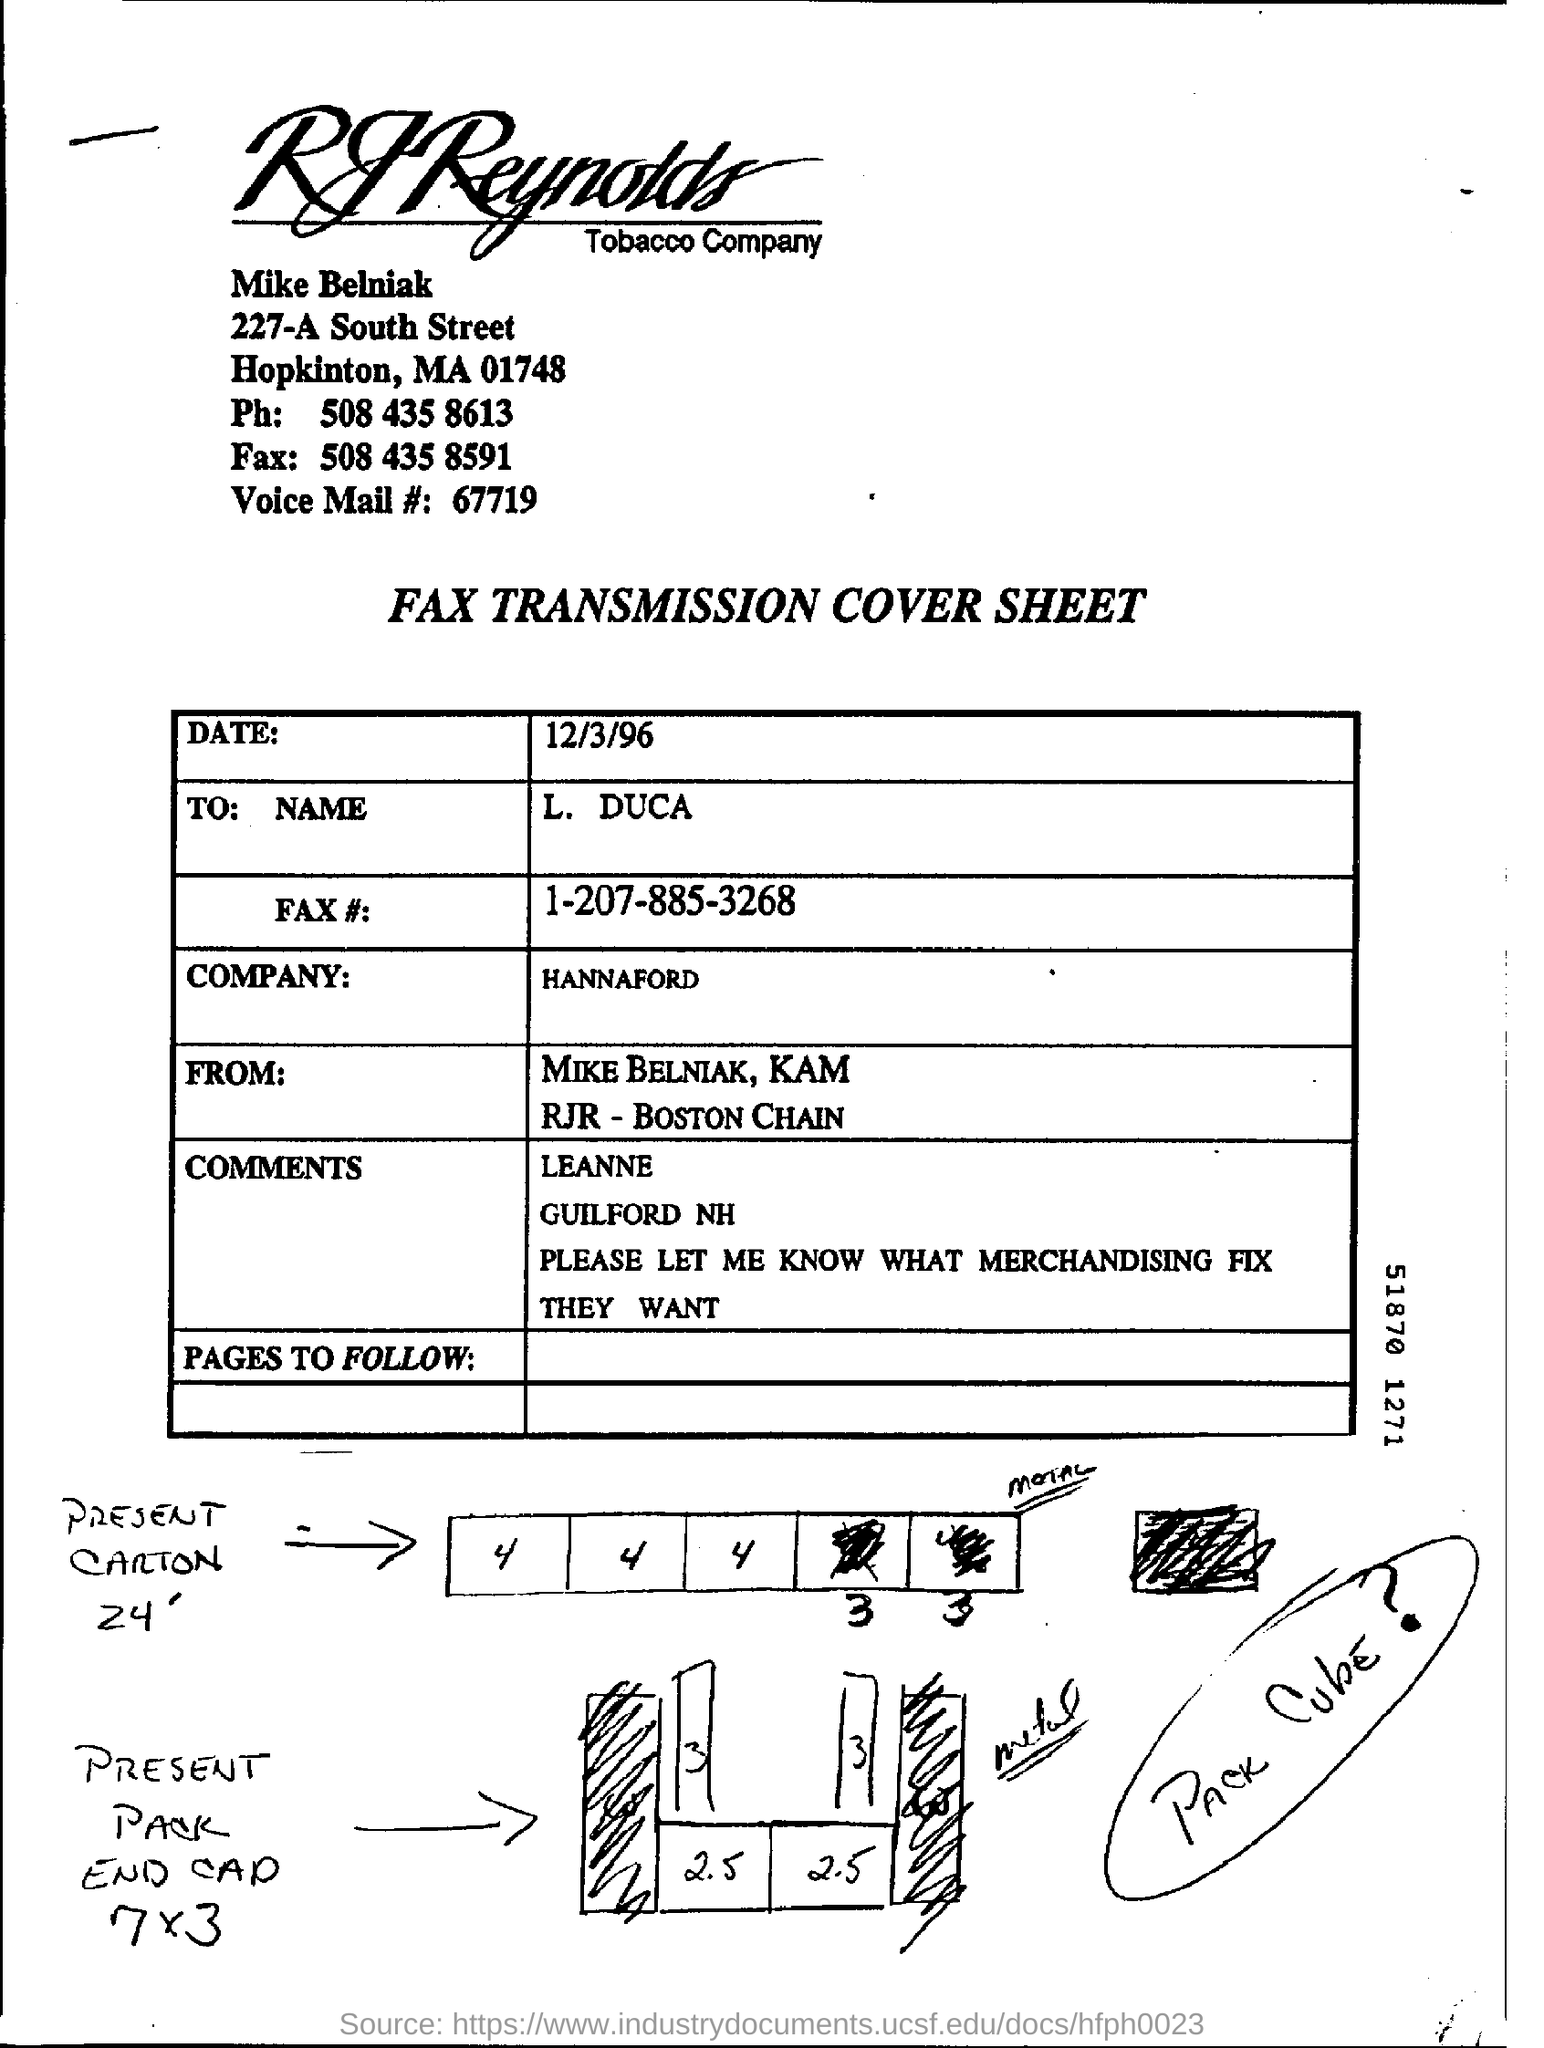What is the phone number of the mike belniak?
Provide a short and direct response. 508 435 8613. What is the fax number of the mike belniak?
Offer a terse response. 508 435 8591. 